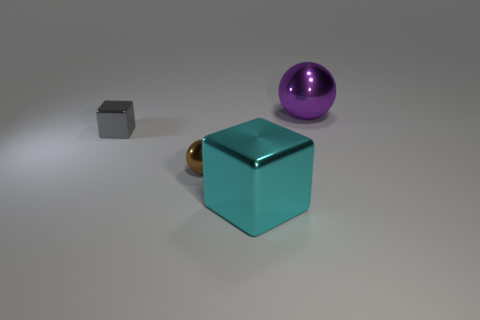Is there a large red thing that has the same material as the tiny brown ball?
Ensure brevity in your answer.  No. Do the tiny block and the cyan cube have the same material?
Offer a terse response. Yes. What number of cyan objects are large metallic blocks or big metal objects?
Offer a very short reply. 1. Is the number of big purple spheres on the left side of the large purple thing greater than the number of tiny gray metallic objects?
Offer a very short reply. No. Is there a small thing that has the same color as the big cube?
Your answer should be compact. No. How big is the gray thing?
Provide a short and direct response. Small. Does the large cube have the same color as the small shiny ball?
Offer a very short reply. No. How many objects are either brown shiny spheres or shiny blocks that are right of the tiny gray shiny thing?
Make the answer very short. 2. Are there the same number of gray metallic cylinders and gray metal blocks?
Provide a succinct answer. No. How many metallic blocks are behind the metal ball on the left side of the ball that is right of the big cyan cube?
Make the answer very short. 1. 